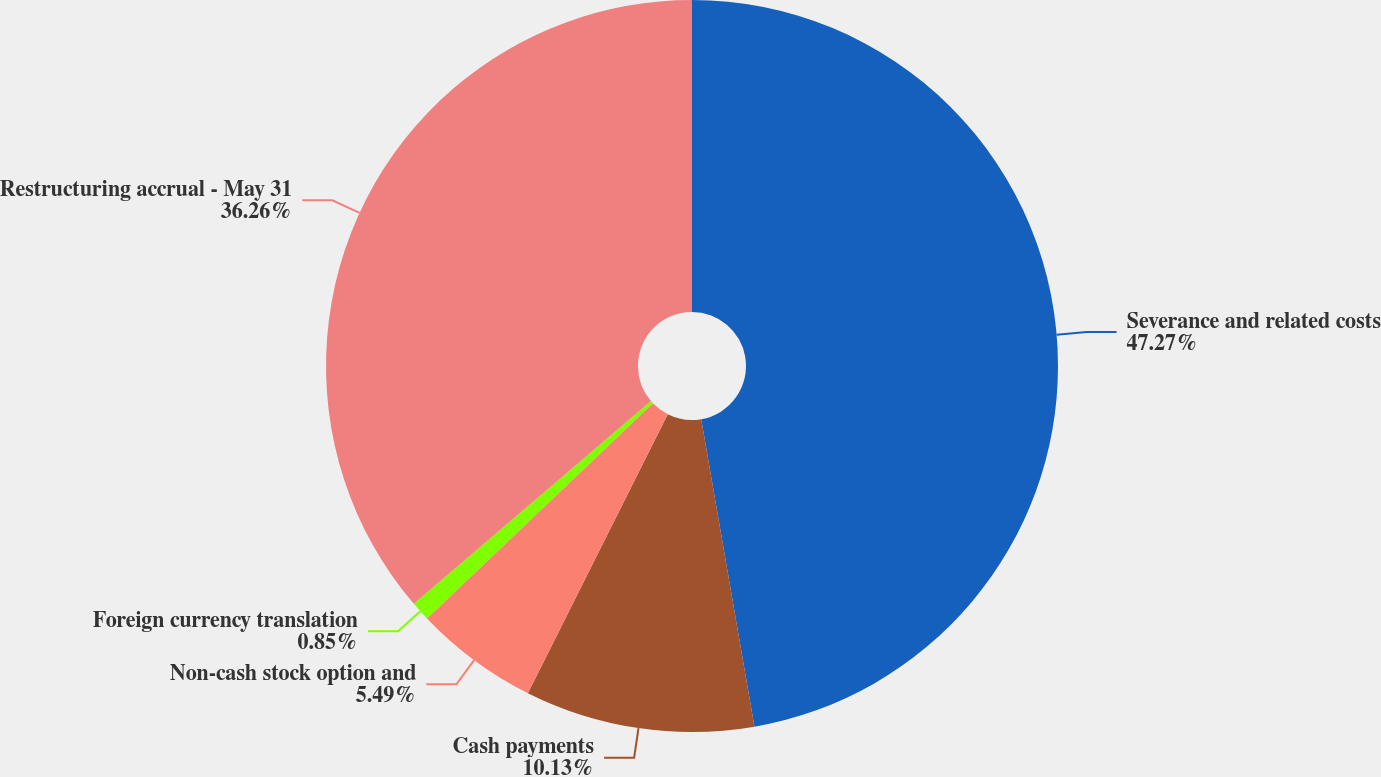<chart> <loc_0><loc_0><loc_500><loc_500><pie_chart><fcel>Severance and related costs<fcel>Cash payments<fcel>Non-cash stock option and<fcel>Foreign currency translation<fcel>Restructuring accrual - May 31<nl><fcel>47.27%<fcel>10.13%<fcel>5.49%<fcel>0.85%<fcel>36.26%<nl></chart> 